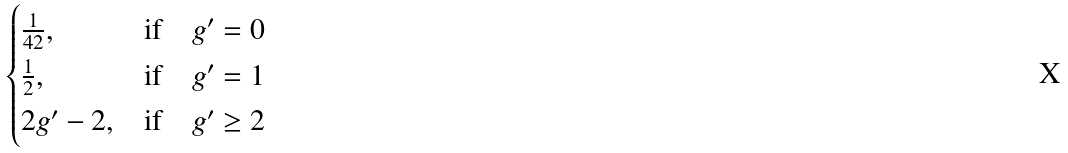<formula> <loc_0><loc_0><loc_500><loc_500>\begin{cases} \frac { 1 } { 4 2 } , & \text {if} \quad g ^ { \prime } = 0 \\ \frac { 1 } { 2 } , & \text {if} \quad g ^ { \prime } = 1 \\ 2 g ^ { \prime } - 2 , & \text {if} \quad g ^ { \prime } \geq 2 \\ \end{cases}</formula> 